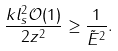Convert formula to latex. <formula><loc_0><loc_0><loc_500><loc_500>\frac { k l _ { s } ^ { 2 } \mathcal { O } ( 1 ) } { 2 z ^ { 2 } } \geq \frac { 1 } { \tilde { E } ^ { 2 } } .</formula> 